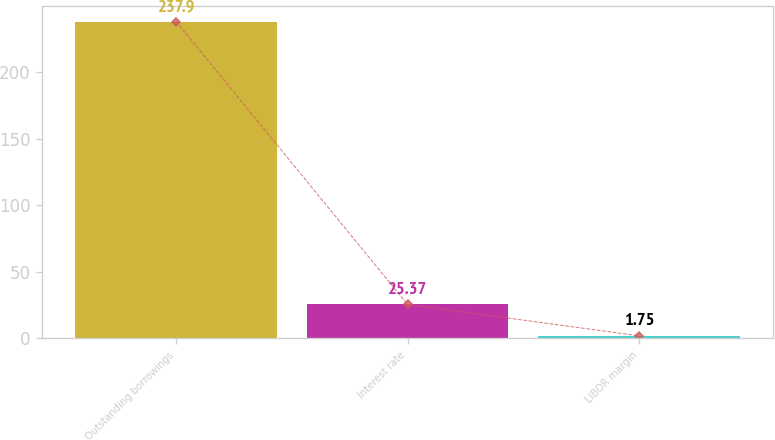<chart> <loc_0><loc_0><loc_500><loc_500><bar_chart><fcel>Outstanding borrowings<fcel>Interest rate<fcel>LIBOR margin<nl><fcel>237.9<fcel>25.37<fcel>1.75<nl></chart> 